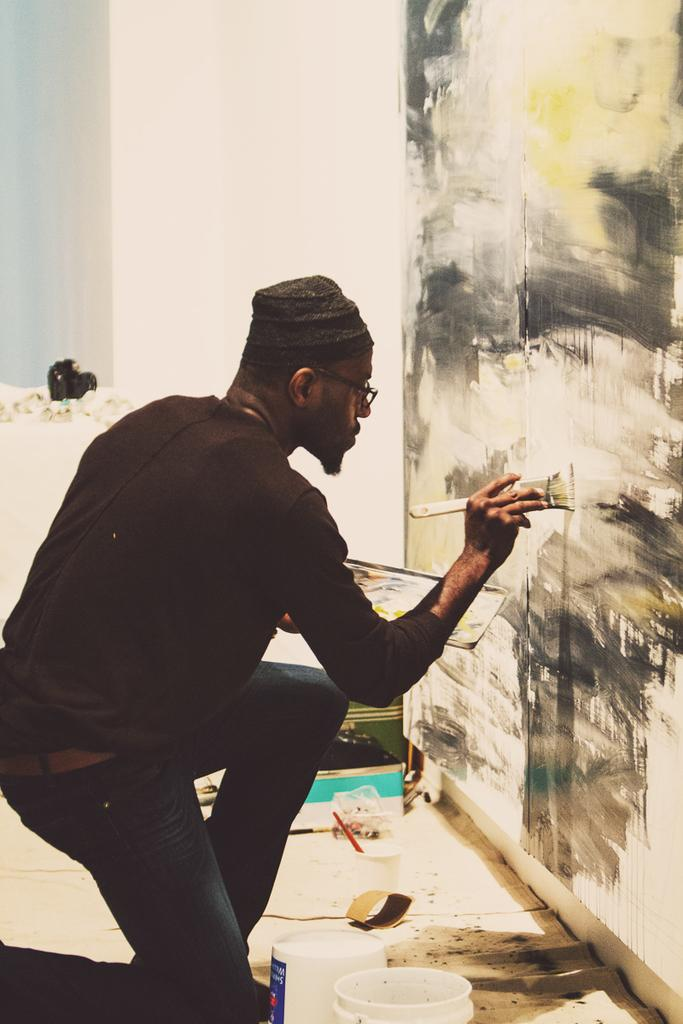What is the person in the image doing? The person in the image is painting. What surface is the person painting on? The person is painting on a wall. What can be seen on the floor in the image? There are buckets and other objects on the floor in the image. What type of architectural feature is present in the image? There is a pillar in the image. What type of beef is being cooked in the middle of the image? There is no beef or cooking activity present in the image; it features a person painting on a wall. 